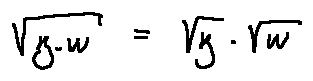Convert formula to latex. <formula><loc_0><loc_0><loc_500><loc_500>\sqrt { z w } = \sqrt { z } \sqrt { w }</formula> 